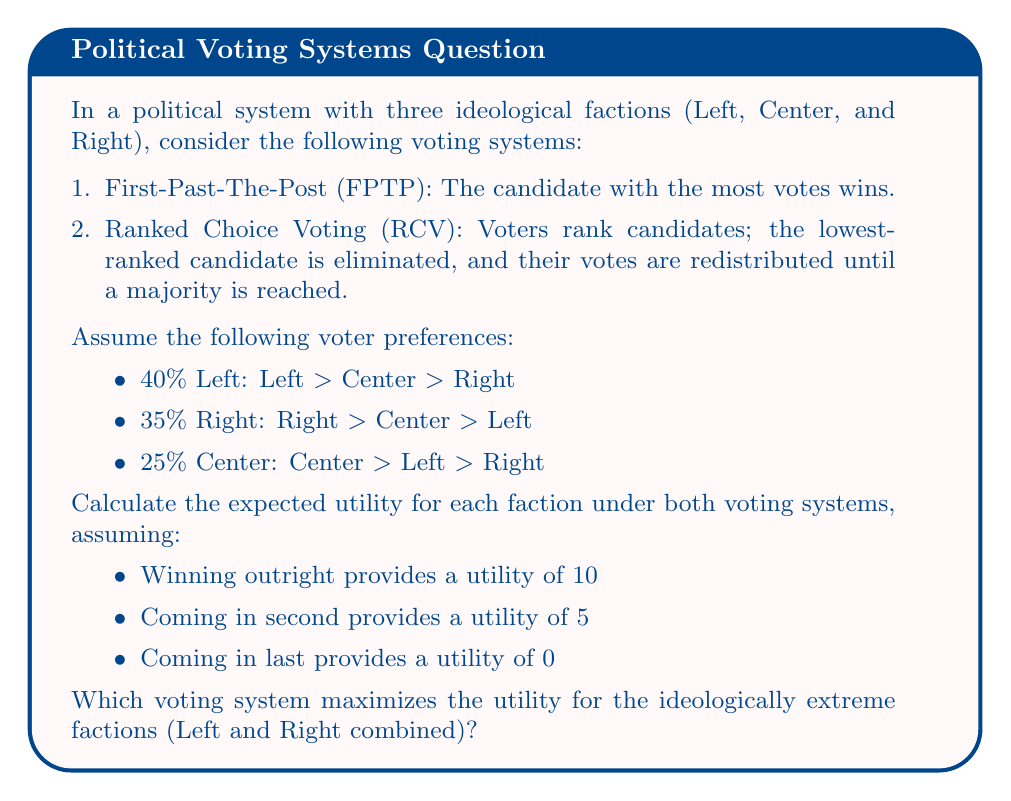Help me with this question. Let's approach this step-by-step using game theory principles:

1. First-Past-The-Post (FPTP):
   Under FPTP, Left wins with 40% of the vote.
   
   Utilities:
   Left: $U_L = 10$
   Right: $U_R = 5$
   Center: $U_C = 0$

2. Ranked Choice Voting (RCV):
   In the first round, Center is eliminated with 25%.
   In the second round, Left wins with 65% (40% + 25%) vs Right's 35%.
   
   Utilities:
   Left: $U_L = 10$
   Right: $U_R = 5$
   Center: $U_C = 0$

3. Expected Utility Calculation:
   For FPTP:
   $$E(U_{FPTP}) = 0.4 \cdot U_L + 0.35 \cdot U_R + 0.25 \cdot U_C$$
   $$E(U_{FPTP}) = 0.4 \cdot 10 + 0.35 \cdot 5 + 0.25 \cdot 0 = 5.75$$

   For RCV:
   $$E(U_{RCV}) = 0.4 \cdot U_L + 0.35 \cdot U_R + 0.25 \cdot U_C$$
   $$E(U_{RCV}) = 0.4 \cdot 10 + 0.35 \cdot 5 + 0.25 \cdot 0 = 5.75$$

4. Utility for Extreme Factions (Left and Right combined):
   For FPTP: $U_{Extreme_{FPTP}} = 10 + 5 = 15$
   For RCV: $U_{Extreme_{RCV}} = 10 + 5 = 15$

Both voting systems yield the same expected utility and the same utility for extreme factions. This aligns with the persona's belief in ideology-based decision-making, as both systems maintain the dominance of ideological extremes over the center.
Answer: Both First-Past-The-Post and Ranked Choice Voting systems yield the same expected utility of 5.75 and the same utility of 15 for the extreme factions combined. Therefore, both voting systems equally maximize the utility for the ideologically extreme factions. 